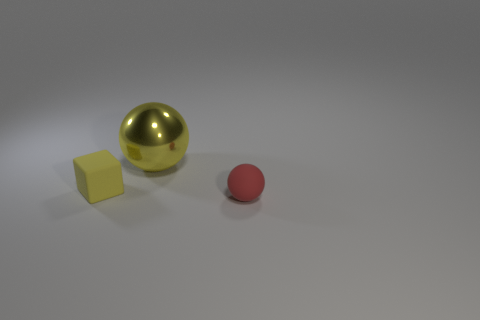Is there any other thing that is the same size as the yellow metal thing?
Offer a very short reply. No. Do the shiny thing and the tiny matte cube have the same color?
Offer a terse response. Yes. Are there any other things that are the same material as the big yellow object?
Offer a terse response. No. Is there any other thing that has the same color as the tiny sphere?
Keep it short and to the point. No. Are there more things to the left of the big shiny object than yellow rubber cubes that are right of the small yellow matte cube?
Keep it short and to the point. Yes. How many other rubber spheres have the same size as the yellow sphere?
Your answer should be very brief. 0. Is the number of yellow shiny things that are in front of the small red matte thing less than the number of red balls in front of the large yellow ball?
Make the answer very short. Yes. Are there any tiny yellow metallic objects that have the same shape as the red matte object?
Offer a terse response. No. Does the small red thing have the same shape as the tiny yellow thing?
Provide a short and direct response. No. How many small objects are either purple things or yellow cubes?
Offer a very short reply. 1. 